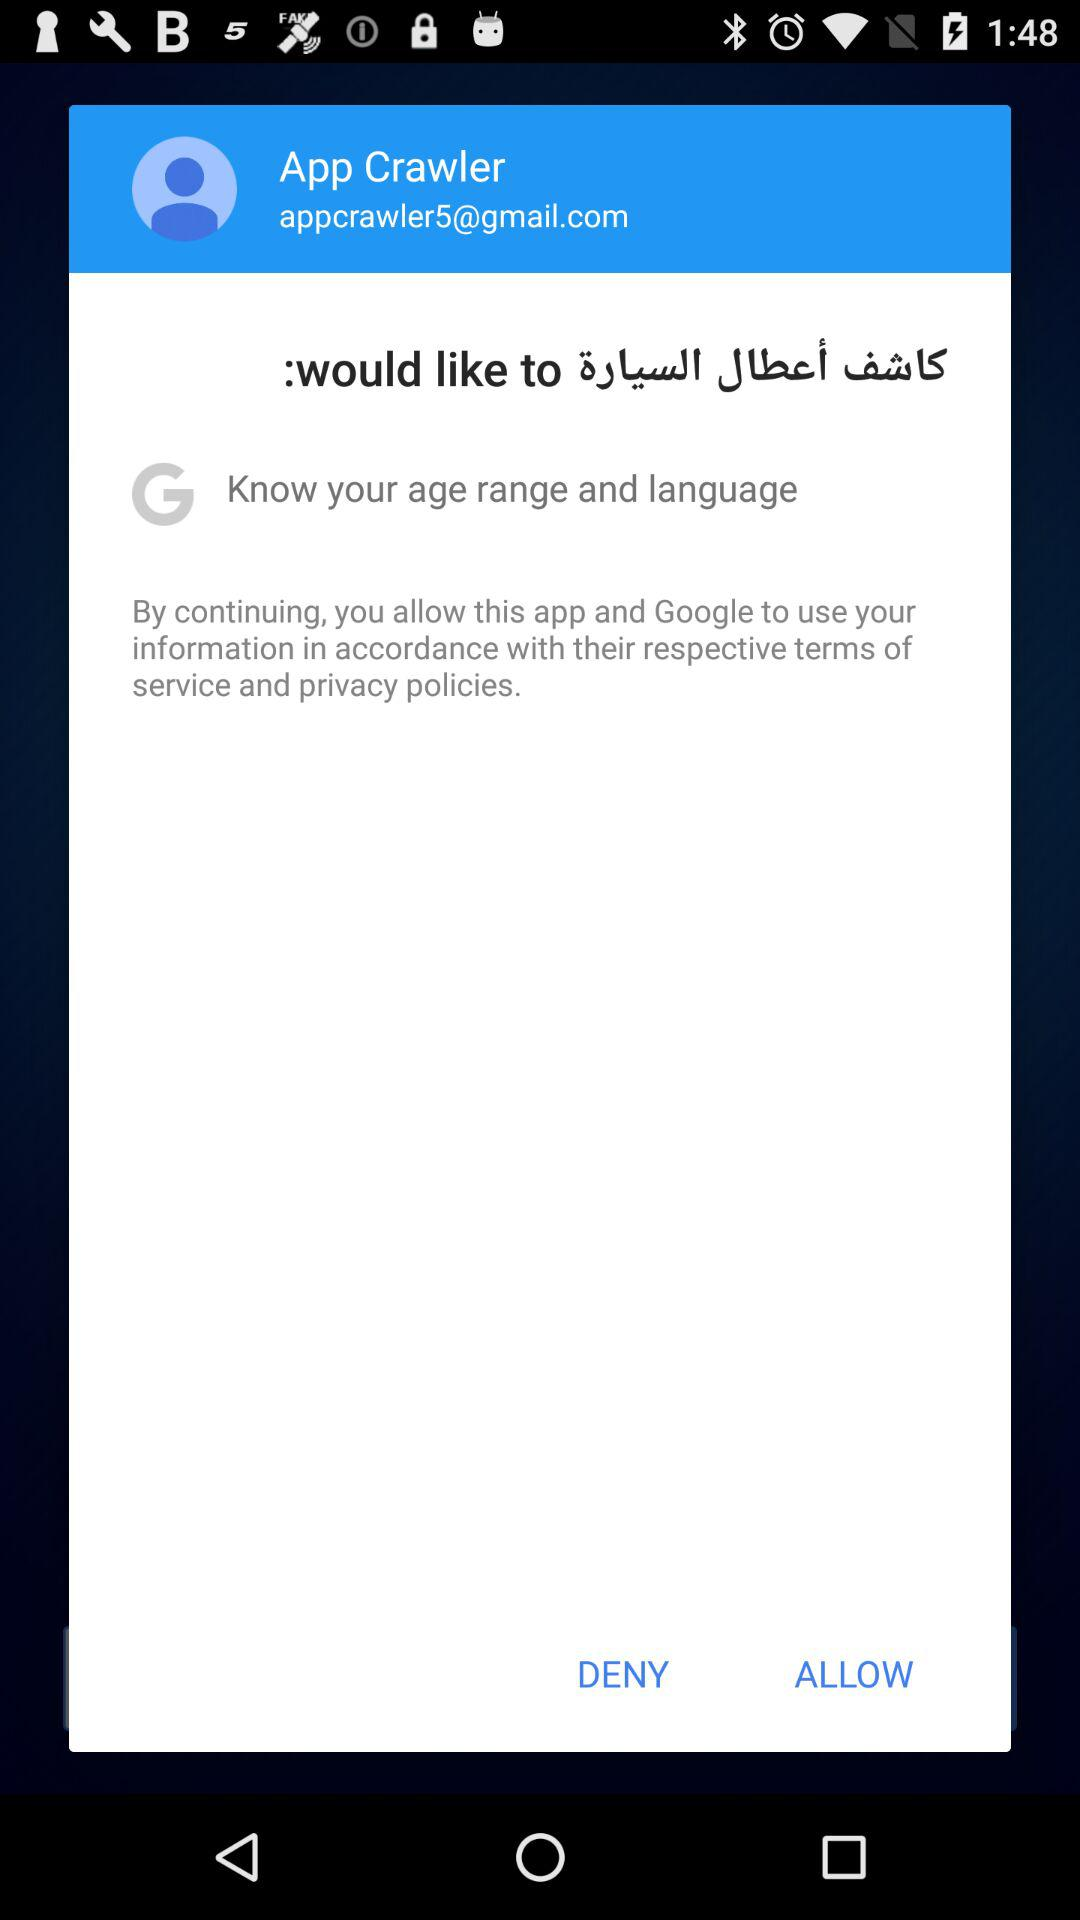What is the name of the user? The name of the user is App Crawler. 